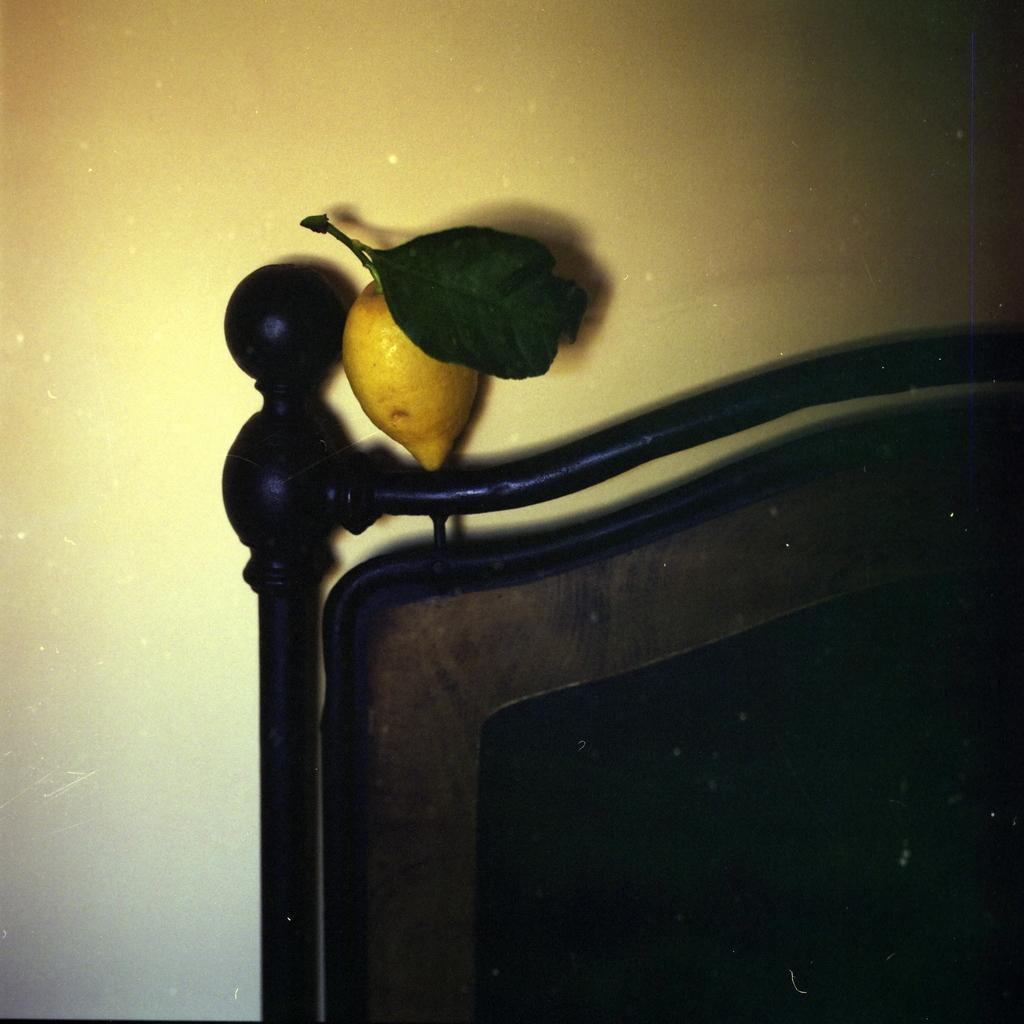What type of object is made of wood in the picture? There is a wooden object in the picture. What is on the wooden object? There is a yellow color fruit on the wooden object. What can be seen in the background of the picture? There is a wall visible in the background of the picture. What type of sound does the clock make in the picture? There is no clock present in the picture, so it is not possible to determine the sound it might make. 